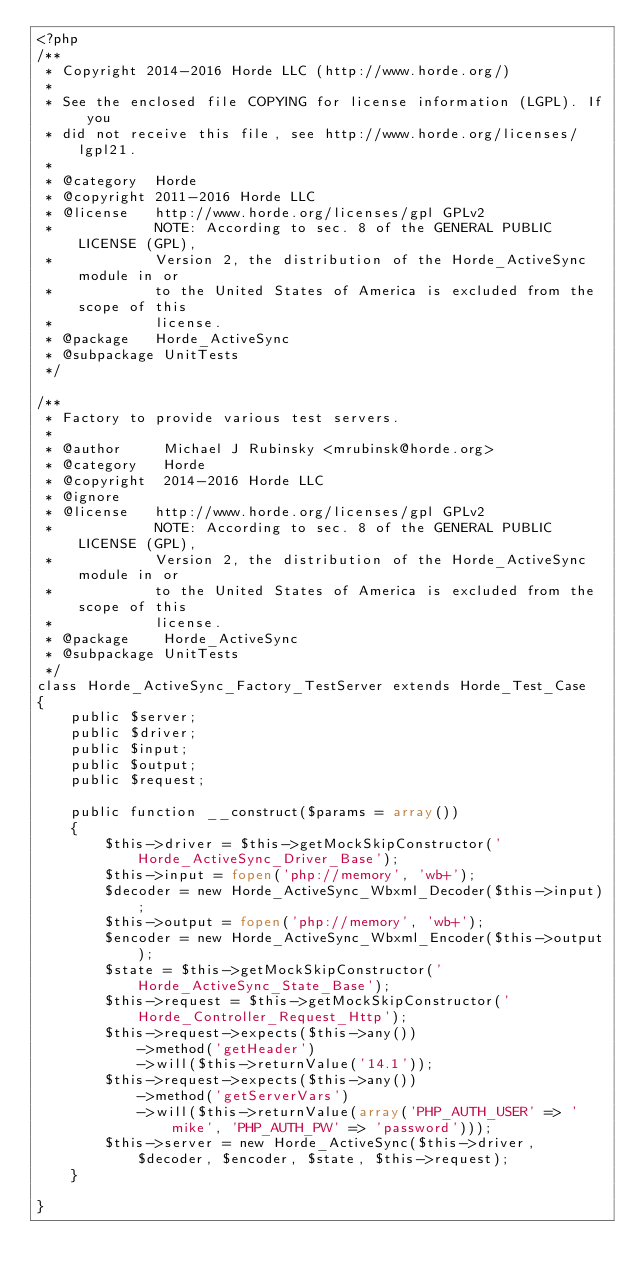<code> <loc_0><loc_0><loc_500><loc_500><_PHP_><?php
/**
 * Copyright 2014-2016 Horde LLC (http://www.horde.org/)
 *
 * See the enclosed file COPYING for license information (LGPL). If you
 * did not receive this file, see http://www.horde.org/licenses/lgpl21.
 *
 * @category  Horde
 * @copyright 2011-2016 Horde LLC
 * @license   http://www.horde.org/licenses/gpl GPLv2
 *            NOTE: According to sec. 8 of the GENERAL PUBLIC LICENSE (GPL),
 *            Version 2, the distribution of the Horde_ActiveSync module in or
 *            to the United States of America is excluded from the scope of this
 *            license.
 * @package   Horde_ActiveSync
 * @subpackage UnitTests
 */

/**
 * Factory to provide various test servers.
 *
 * @author     Michael J Rubinsky <mrubinsk@horde.org>
 * @category   Horde
 * @copyright  2014-2016 Horde LLC
 * @ignore
 * @license   http://www.horde.org/licenses/gpl GPLv2
 *            NOTE: According to sec. 8 of the GENERAL PUBLIC LICENSE (GPL),
 *            Version 2, the distribution of the Horde_ActiveSync module in or
 *            to the United States of America is excluded from the scope of this
 *            license.
 * @package    Horde_ActiveSync
 * @subpackage UnitTests
 */
class Horde_ActiveSync_Factory_TestServer extends Horde_Test_Case
{
    public $server;
    public $driver;
    public $input;
    public $output;
    public $request;

    public function __construct($params = array())
    {
        $this->driver = $this->getMockSkipConstructor('Horde_ActiveSync_Driver_Base');
        $this->input = fopen('php://memory', 'wb+');
        $decoder = new Horde_ActiveSync_Wbxml_Decoder($this->input);
        $this->output = fopen('php://memory', 'wb+');
        $encoder = new Horde_ActiveSync_Wbxml_Encoder($this->output);
        $state = $this->getMockSkipConstructor('Horde_ActiveSync_State_Base');
        $this->request = $this->getMockSkipConstructor('Horde_Controller_Request_Http');
        $this->request->expects($this->any())
            ->method('getHeader')
            ->will($this->returnValue('14.1'));
        $this->request->expects($this->any())
            ->method('getServerVars')
            ->will($this->returnValue(array('PHP_AUTH_USER' => 'mike', 'PHP_AUTH_PW' => 'password')));
        $this->server = new Horde_ActiveSync($this->driver, $decoder, $encoder, $state, $this->request);
    }

}</code> 